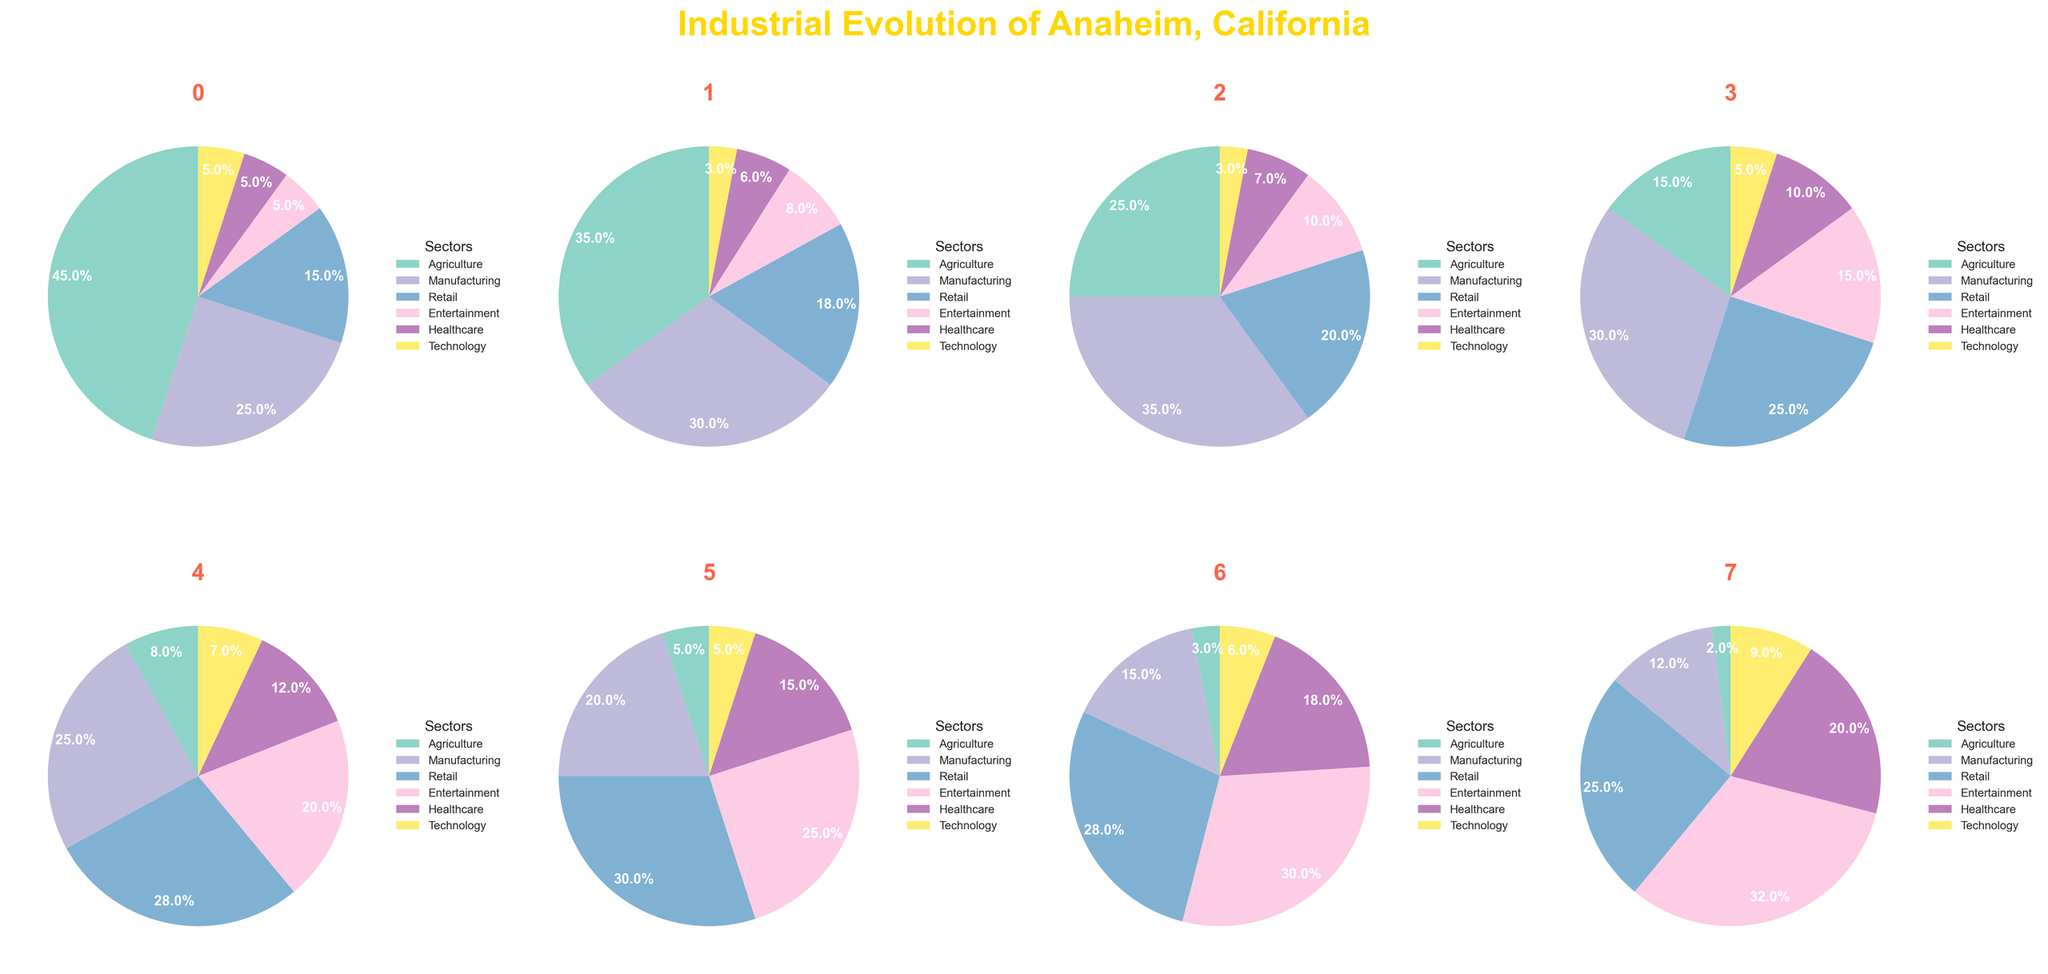Which sector shows a continuous decline from the 1950s to the 2020s? By visually inspecting the pie charts for each decade, we notice that agriculture shows a continuous decrease in size from the 1950s to the 2020s.
Answer: Agriculture Which sector becomes the largest in the 2020s? By looking at the pie chart for the 2020s, entertainment is the largest sector as it occupies the highest percentage area of the pie.
Answer: Entertainment How does the percentage of the manufacturing sector change from the 1950s to the 1960s? Manufacturing increases from 25% in the 1950s to 30% in the 1960s. This is a change of 30 - 25 = 5%.
Answer: 5% Which two sectors saw the most significant increase and decrease in their percentages from the 1950s to the 2020s? Agriculture decreased the most, from 45% to 2%. Entertainment increased the most, from 5% to 32%.
Answer: Agriculture (decrease), Entertainment (increase) Between the 1980s and the 1990s, which sector increased its share the most and by what percentage? Entertainment increased from 15% in the 1980s to 20% in the 1990s, which is an increase of 20 - 15 = 5%.
Answer: Entertainment, 5% What is the total percentage of the Retail sector across all decades? Summing up the percentages for retail: 15 + 18 + 20 + 25 + 28 + 30 + 28 + 25 = 189%.
Answer: 189% Which sector has the smallest percentage change between any two consecutive decades? By comparing the percentages of each sector between consecutive decades, Technology shows the least volatility with minor changes, especially from the 1970s to 1980s, 3% to 5%, and from 2010s to 2020s, 6% to 9%.
Answer: Technology Between the 1950s and the 2010s, which sector had the largest percentage increase? By comparing the two decades, Entertainment sector increased significantly from 5% to 30%. This is an increase of 30 - 5 = 25%.
Answer: Entertainment What percentage of the technology sector shares in the 2020s compared to healthcare in the same decade? In the 2020s, technology is 9% and healthcare is 20%. Compared to healthcare, technology is 9/20 = 0.45, which is 45%.
Answer: 45% 